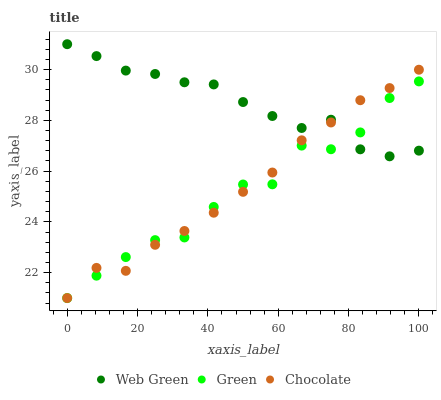Does Green have the minimum area under the curve?
Answer yes or no. Yes. Does Web Green have the maximum area under the curve?
Answer yes or no. Yes. Does Chocolate have the minimum area under the curve?
Answer yes or no. No. Does Chocolate have the maximum area under the curve?
Answer yes or no. No. Is Chocolate the smoothest?
Answer yes or no. Yes. Is Green the roughest?
Answer yes or no. Yes. Is Web Green the smoothest?
Answer yes or no. No. Is Web Green the roughest?
Answer yes or no. No. Does Green have the lowest value?
Answer yes or no. Yes. Does Web Green have the lowest value?
Answer yes or no. No. Does Web Green have the highest value?
Answer yes or no. Yes. Does Chocolate have the highest value?
Answer yes or no. No. Does Green intersect Chocolate?
Answer yes or no. Yes. Is Green less than Chocolate?
Answer yes or no. No. Is Green greater than Chocolate?
Answer yes or no. No. 